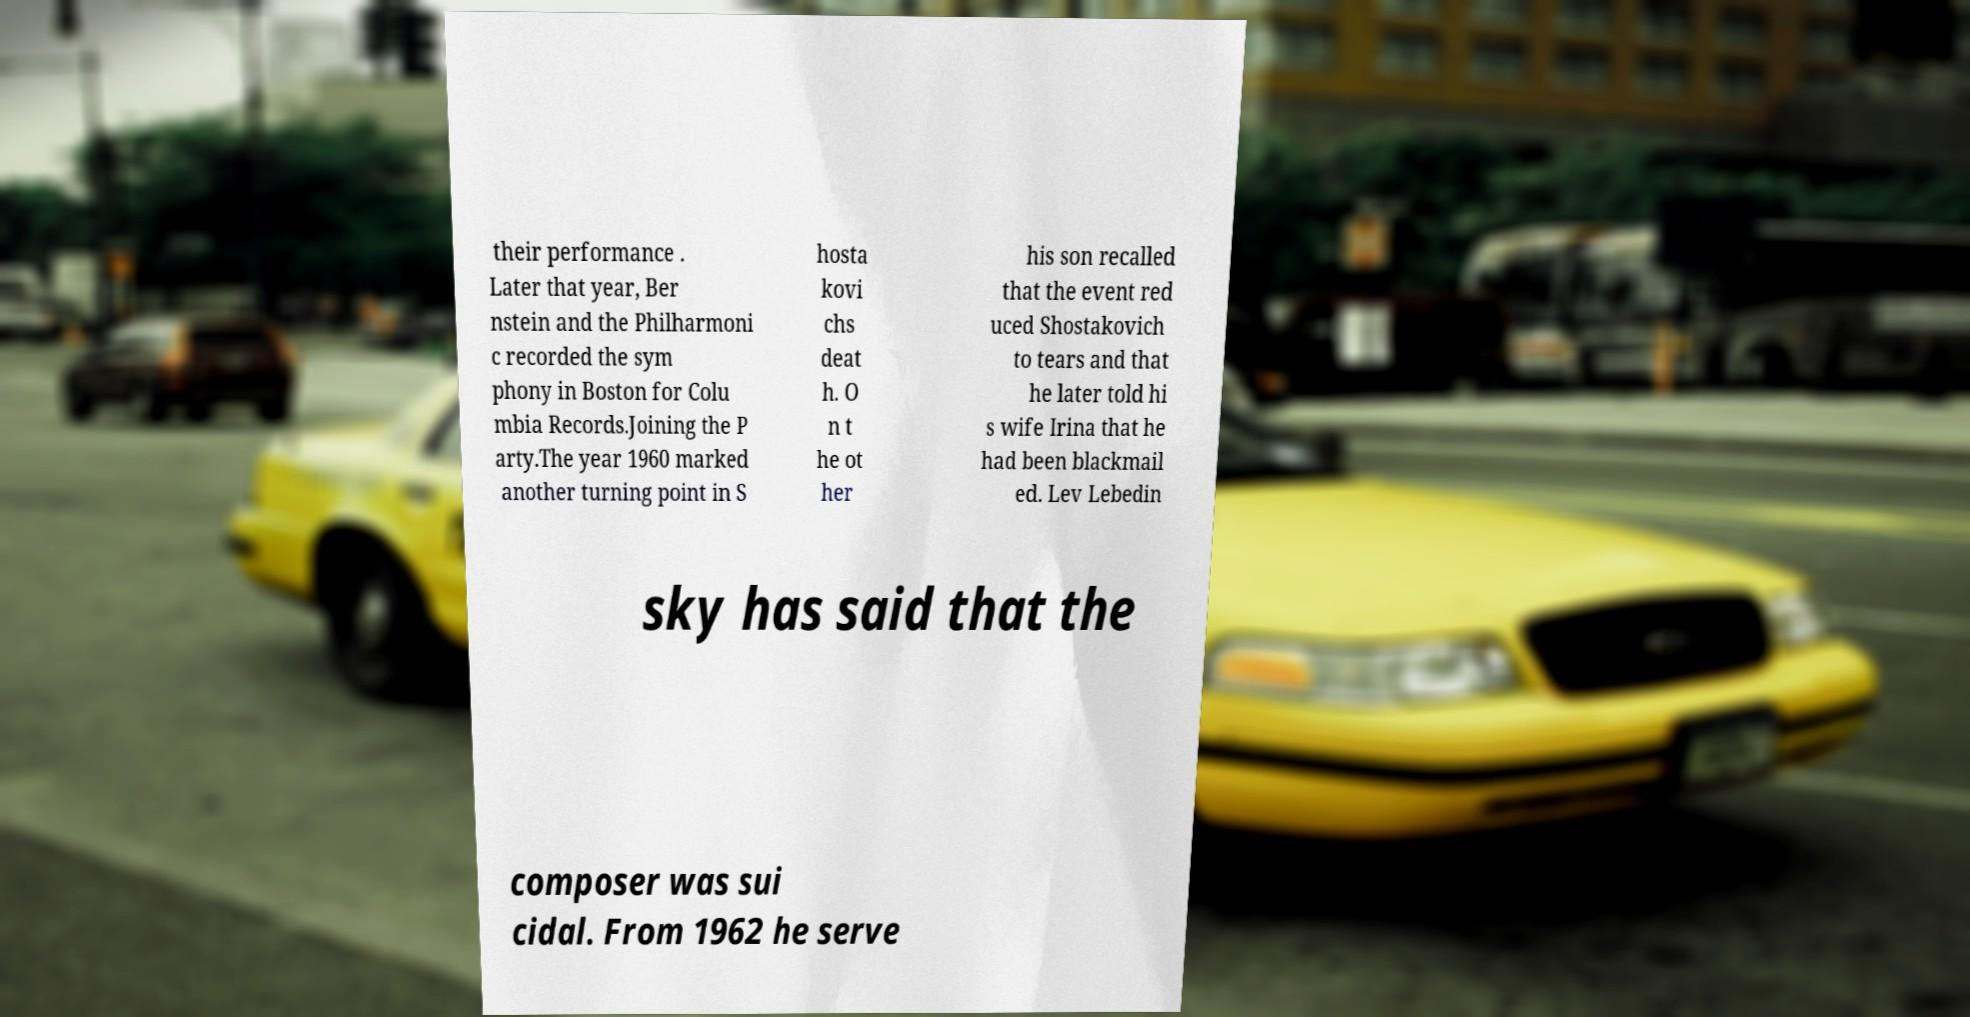Please read and relay the text visible in this image. What does it say? their performance . Later that year, Ber nstein and the Philharmoni c recorded the sym phony in Boston for Colu mbia Records.Joining the P arty.The year 1960 marked another turning point in S hosta kovi chs deat h. O n t he ot her his son recalled that the event red uced Shostakovich to tears and that he later told hi s wife Irina that he had been blackmail ed. Lev Lebedin sky has said that the composer was sui cidal. From 1962 he serve 